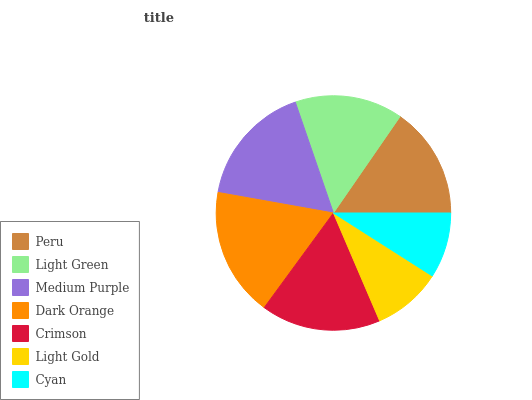Is Cyan the minimum?
Answer yes or no. Yes. Is Dark Orange the maximum?
Answer yes or no. Yes. Is Light Green the minimum?
Answer yes or no. No. Is Light Green the maximum?
Answer yes or no. No. Is Peru greater than Light Green?
Answer yes or no. Yes. Is Light Green less than Peru?
Answer yes or no. Yes. Is Light Green greater than Peru?
Answer yes or no. No. Is Peru less than Light Green?
Answer yes or no. No. Is Peru the high median?
Answer yes or no. Yes. Is Peru the low median?
Answer yes or no. Yes. Is Cyan the high median?
Answer yes or no. No. Is Cyan the low median?
Answer yes or no. No. 